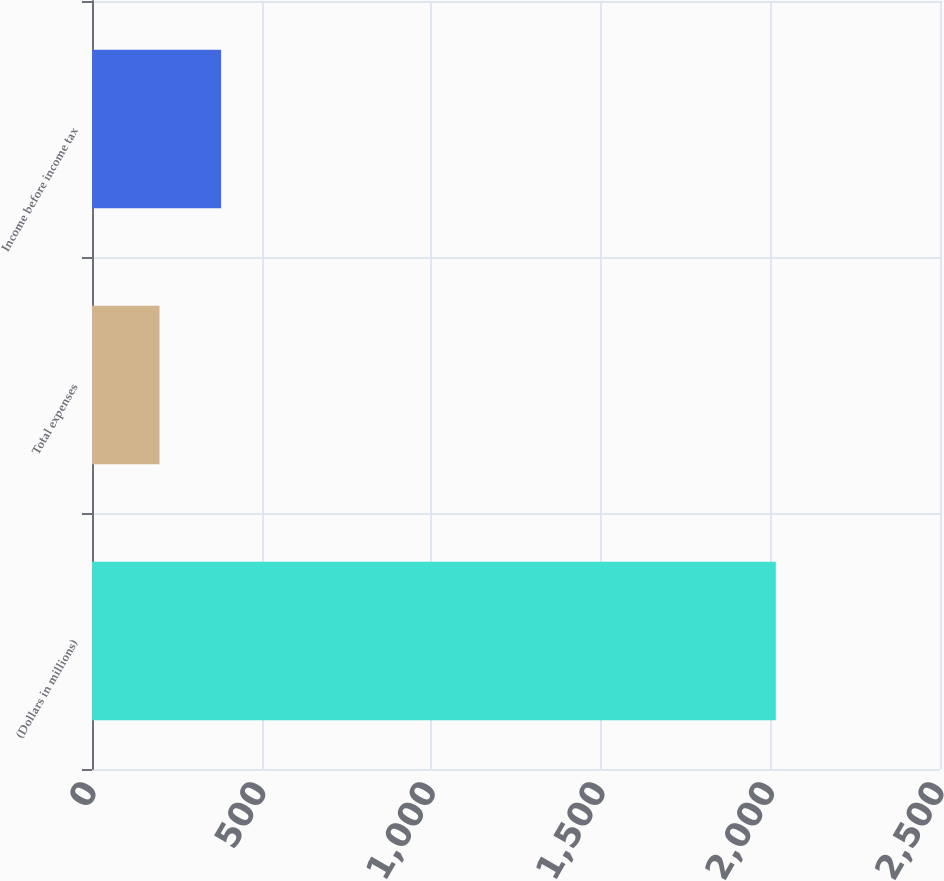<chart> <loc_0><loc_0><loc_500><loc_500><bar_chart><fcel>(Dollars in millions)<fcel>Total expenses<fcel>Income before income tax<nl><fcel>2016<fcel>199<fcel>380.7<nl></chart> 